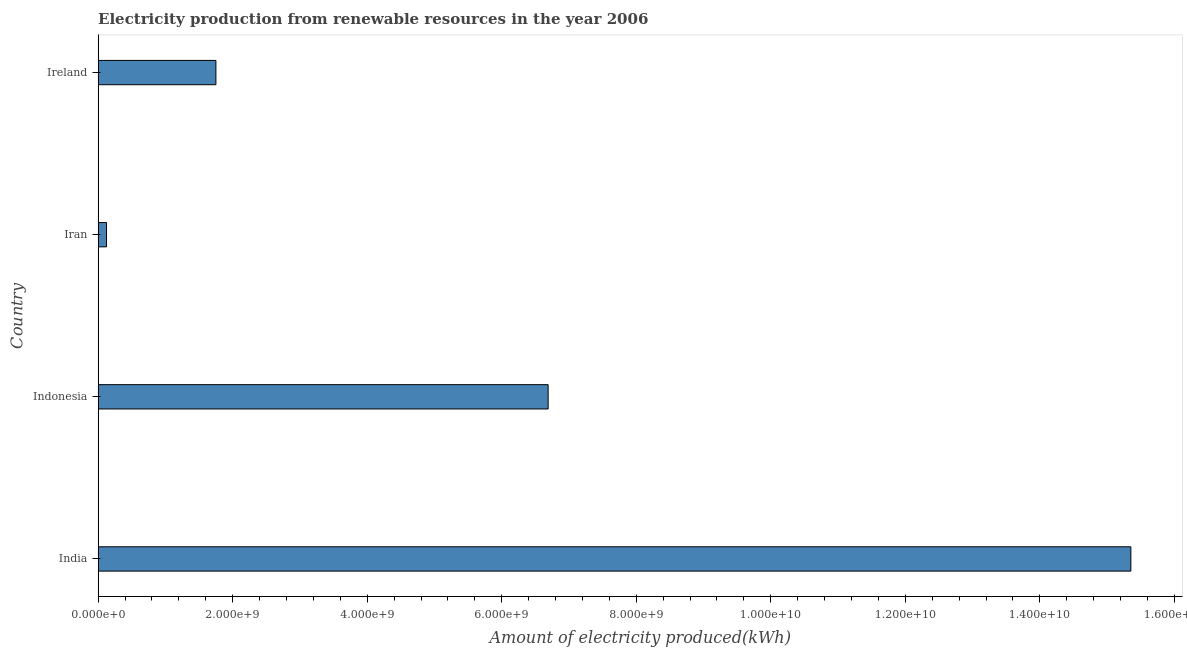Does the graph contain any zero values?
Provide a succinct answer. No. Does the graph contain grids?
Provide a short and direct response. No. What is the title of the graph?
Your answer should be very brief. Electricity production from renewable resources in the year 2006. What is the label or title of the X-axis?
Provide a short and direct response. Amount of electricity produced(kWh). What is the label or title of the Y-axis?
Offer a terse response. Country. What is the amount of electricity produced in Ireland?
Make the answer very short. 1.75e+09. Across all countries, what is the maximum amount of electricity produced?
Offer a very short reply. 1.54e+1. Across all countries, what is the minimum amount of electricity produced?
Your response must be concise. 1.25e+08. In which country was the amount of electricity produced minimum?
Make the answer very short. Iran. What is the sum of the amount of electricity produced?
Make the answer very short. 2.39e+1. What is the difference between the amount of electricity produced in Indonesia and Ireland?
Your answer should be compact. 4.94e+09. What is the average amount of electricity produced per country?
Offer a terse response. 5.98e+09. What is the median amount of electricity produced?
Provide a short and direct response. 4.22e+09. In how many countries, is the amount of electricity produced greater than 4400000000 kWh?
Make the answer very short. 2. What is the ratio of the amount of electricity produced in India to that in Ireland?
Ensure brevity in your answer.  8.77. Is the difference between the amount of electricity produced in India and Iran greater than the difference between any two countries?
Offer a terse response. Yes. What is the difference between the highest and the second highest amount of electricity produced?
Provide a short and direct response. 8.66e+09. Is the sum of the amount of electricity produced in India and Indonesia greater than the maximum amount of electricity produced across all countries?
Keep it short and to the point. Yes. What is the difference between the highest and the lowest amount of electricity produced?
Provide a short and direct response. 1.52e+1. How many bars are there?
Your answer should be compact. 4. How many countries are there in the graph?
Provide a succinct answer. 4. What is the difference between two consecutive major ticks on the X-axis?
Ensure brevity in your answer.  2.00e+09. Are the values on the major ticks of X-axis written in scientific E-notation?
Make the answer very short. Yes. What is the Amount of electricity produced(kWh) in India?
Your response must be concise. 1.54e+1. What is the Amount of electricity produced(kWh) in Indonesia?
Your answer should be compact. 6.69e+09. What is the Amount of electricity produced(kWh) in Iran?
Keep it short and to the point. 1.25e+08. What is the Amount of electricity produced(kWh) of Ireland?
Offer a terse response. 1.75e+09. What is the difference between the Amount of electricity produced(kWh) in India and Indonesia?
Your answer should be very brief. 8.66e+09. What is the difference between the Amount of electricity produced(kWh) in India and Iran?
Your answer should be compact. 1.52e+1. What is the difference between the Amount of electricity produced(kWh) in India and Ireland?
Make the answer very short. 1.36e+1. What is the difference between the Amount of electricity produced(kWh) in Indonesia and Iran?
Provide a short and direct response. 6.56e+09. What is the difference between the Amount of electricity produced(kWh) in Indonesia and Ireland?
Keep it short and to the point. 4.94e+09. What is the difference between the Amount of electricity produced(kWh) in Iran and Ireland?
Your answer should be compact. -1.63e+09. What is the ratio of the Amount of electricity produced(kWh) in India to that in Indonesia?
Keep it short and to the point. 2.29. What is the ratio of the Amount of electricity produced(kWh) in India to that in Iran?
Provide a short and direct response. 122.82. What is the ratio of the Amount of electricity produced(kWh) in India to that in Ireland?
Make the answer very short. 8.77. What is the ratio of the Amount of electricity produced(kWh) in Indonesia to that in Iran?
Ensure brevity in your answer.  53.52. What is the ratio of the Amount of electricity produced(kWh) in Indonesia to that in Ireland?
Offer a very short reply. 3.82. What is the ratio of the Amount of electricity produced(kWh) in Iran to that in Ireland?
Offer a very short reply. 0.07. 